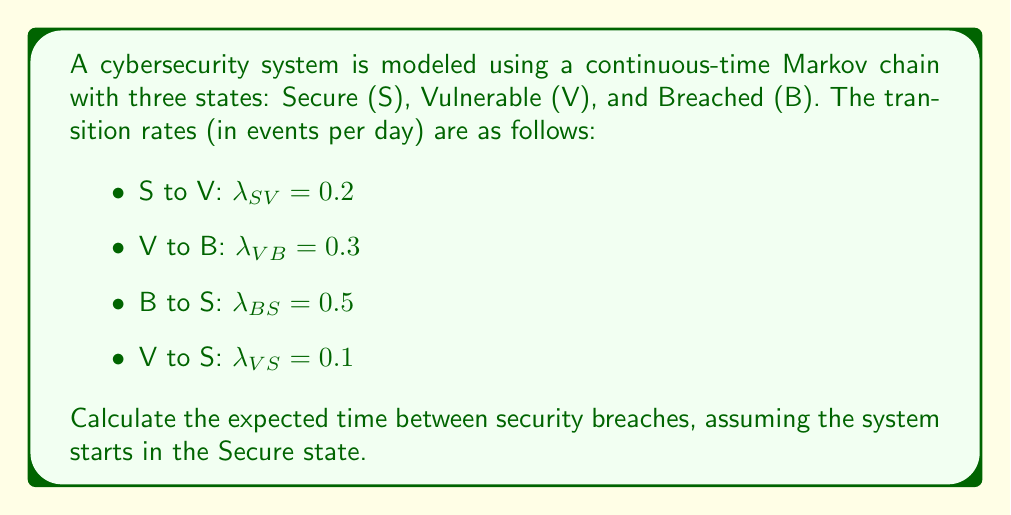Solve this math problem. To solve this problem, we'll follow these steps:

1) First, we need to set up the infinitesimal generator matrix Q:

   $$Q = \begin{bmatrix}
   -0.2 & 0.2 & 0 \\
   0.1 & -0.4 & 0.3 \\
   0.5 & 0 & -0.5
   \end{bmatrix}$$

2) The stationary distribution π = [π_S, π_V, π_B] satisfies πQ = 0 and π_S + π_V + π_B = 1. Solving this system:

   $$\begin{cases}
   -0.2π_S + 0.1π_V + 0.5π_B = 0 \\
   0.2π_S - 0.4π_V = 0 \\
   0.3π_V - 0.5π_B = 0 \\
   π_S + π_V + π_B = 1
   \end{cases}$$

3) Solving this system yields:
   $$π_S = \frac{25}{43}, π_V = \frac{10}{43}, π_B = \frac{8}{43}$$

4) The rate of entering the Breached state is:
   $$r_B = π_V \cdot \lambda_{VB} = \frac{10}{43} \cdot 0.3 = \frac{3}{43}$$

5) The expected time between breaches is the inverse of this rate:
   $$E[T] = \frac{1}{r_B} = \frac{43}{3} \approx 14.33 \text{ days}$$
Answer: $\frac{43}{3}$ days or approximately 14.33 days 